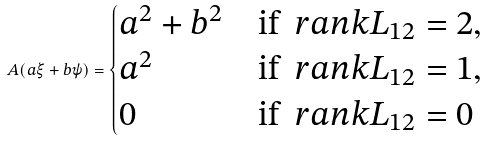Convert formula to latex. <formula><loc_0><loc_0><loc_500><loc_500>A ( a \xi + b \psi ) = \begin{cases} a ^ { 2 } + b ^ { 2 } & \text {if } \ r a n k L _ { 1 2 } = 2 , \\ a ^ { 2 } & \text {if } \ r a n k L _ { 1 2 } = 1 , \\ 0 & \text {if } \ r a n k L _ { 1 2 } = 0 \end{cases}</formula> 